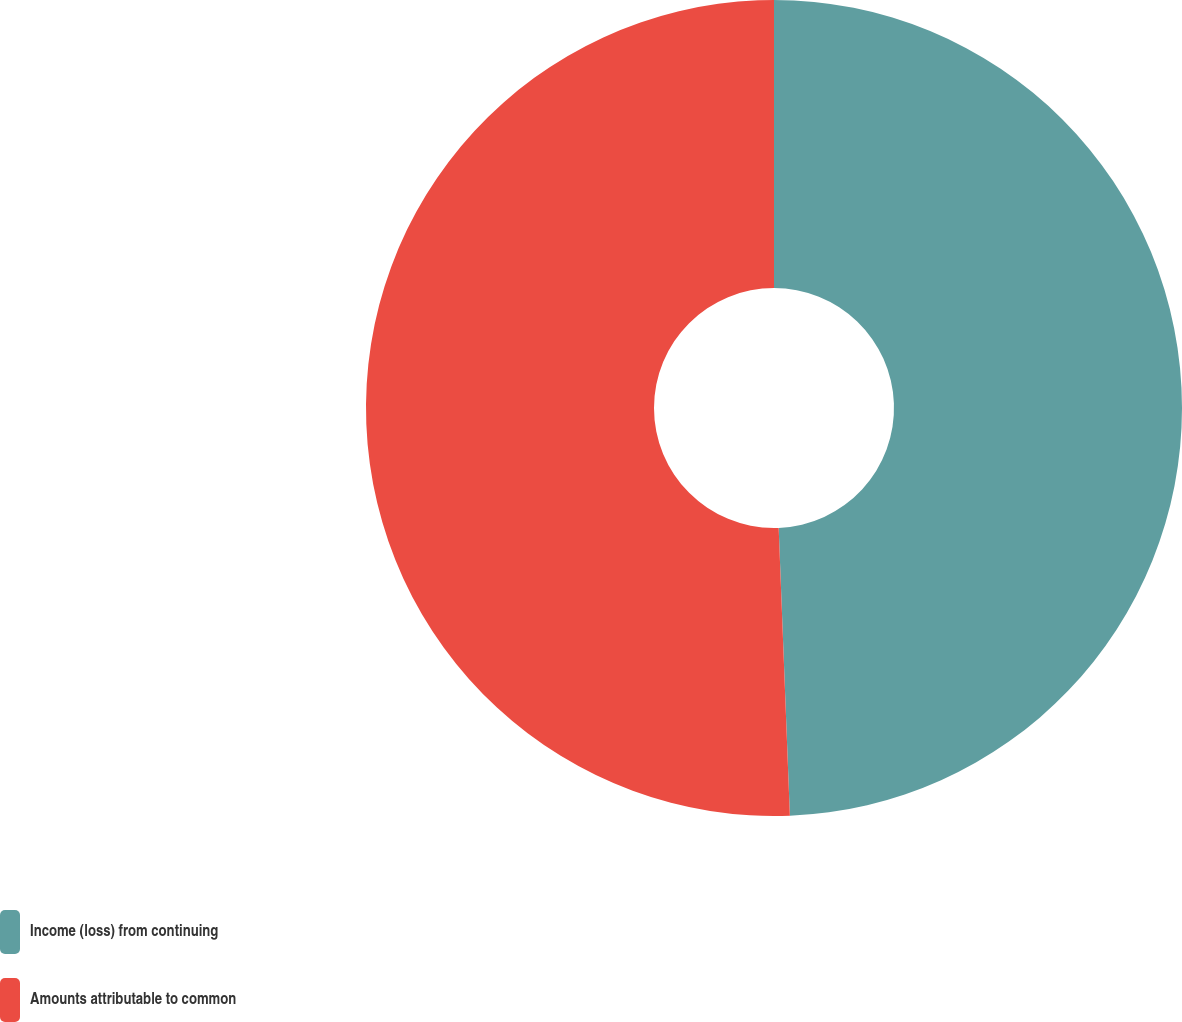<chart> <loc_0><loc_0><loc_500><loc_500><pie_chart><fcel>Income (loss) from continuing<fcel>Amounts attributable to common<nl><fcel>49.38%<fcel>50.62%<nl></chart> 